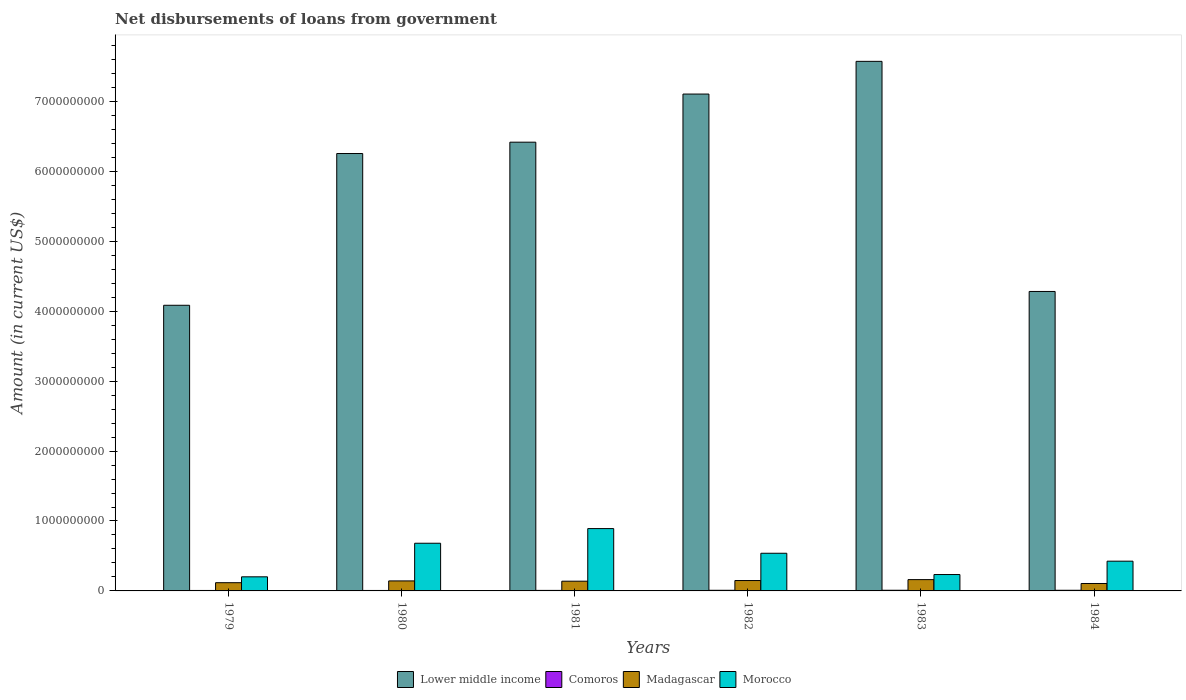How many groups of bars are there?
Your answer should be compact. 6. Are the number of bars per tick equal to the number of legend labels?
Make the answer very short. Yes. How many bars are there on the 1st tick from the right?
Your response must be concise. 4. What is the label of the 1st group of bars from the left?
Make the answer very short. 1979. In how many cases, is the number of bars for a given year not equal to the number of legend labels?
Make the answer very short. 0. What is the amount of loan disbursed from government in Madagascar in 1982?
Your response must be concise. 1.48e+08. Across all years, what is the maximum amount of loan disbursed from government in Madagascar?
Your response must be concise. 1.62e+08. Across all years, what is the minimum amount of loan disbursed from government in Morocco?
Give a very brief answer. 2.02e+08. In which year was the amount of loan disbursed from government in Lower middle income maximum?
Give a very brief answer. 1983. In which year was the amount of loan disbursed from government in Comoros minimum?
Your answer should be compact. 1980. What is the total amount of loan disbursed from government in Madagascar in the graph?
Your answer should be very brief. 8.16e+08. What is the difference between the amount of loan disbursed from government in Madagascar in 1981 and that in 1982?
Keep it short and to the point. -9.49e+06. What is the difference between the amount of loan disbursed from government in Morocco in 1980 and the amount of loan disbursed from government in Lower middle income in 1984?
Make the answer very short. -3.60e+09. What is the average amount of loan disbursed from government in Morocco per year?
Provide a short and direct response. 4.96e+08. In the year 1981, what is the difference between the amount of loan disbursed from government in Comoros and amount of loan disbursed from government in Lower middle income?
Offer a very short reply. -6.41e+09. What is the ratio of the amount of loan disbursed from government in Morocco in 1979 to that in 1982?
Provide a succinct answer. 0.37. Is the amount of loan disbursed from government in Lower middle income in 1979 less than that in 1981?
Your answer should be compact. Yes. Is the difference between the amount of loan disbursed from government in Comoros in 1979 and 1982 greater than the difference between the amount of loan disbursed from government in Lower middle income in 1979 and 1982?
Offer a very short reply. Yes. What is the difference between the highest and the second highest amount of loan disbursed from government in Lower middle income?
Ensure brevity in your answer.  4.68e+08. What is the difference between the highest and the lowest amount of loan disbursed from government in Madagascar?
Offer a very short reply. 5.54e+07. In how many years, is the amount of loan disbursed from government in Lower middle income greater than the average amount of loan disbursed from government in Lower middle income taken over all years?
Give a very brief answer. 4. What does the 2nd bar from the left in 1983 represents?
Your answer should be very brief. Comoros. What does the 4th bar from the right in 1981 represents?
Your answer should be compact. Lower middle income. How many bars are there?
Make the answer very short. 24. Does the graph contain any zero values?
Offer a very short reply. No. How many legend labels are there?
Offer a terse response. 4. How are the legend labels stacked?
Make the answer very short. Horizontal. What is the title of the graph?
Give a very brief answer. Net disbursements of loans from government. Does "OECD members" appear as one of the legend labels in the graph?
Your answer should be compact. No. What is the label or title of the X-axis?
Make the answer very short. Years. What is the label or title of the Y-axis?
Provide a short and direct response. Amount (in current US$). What is the Amount (in current US$) of Lower middle income in 1979?
Make the answer very short. 4.08e+09. What is the Amount (in current US$) in Comoros in 1979?
Provide a short and direct response. 6.61e+06. What is the Amount (in current US$) of Madagascar in 1979?
Your response must be concise. 1.18e+08. What is the Amount (in current US$) in Morocco in 1979?
Offer a very short reply. 2.02e+08. What is the Amount (in current US$) in Lower middle income in 1980?
Give a very brief answer. 6.26e+09. What is the Amount (in current US$) of Comoros in 1980?
Give a very brief answer. 6.48e+06. What is the Amount (in current US$) in Madagascar in 1980?
Your answer should be compact. 1.43e+08. What is the Amount (in current US$) of Morocco in 1980?
Your answer should be compact. 6.82e+08. What is the Amount (in current US$) in Lower middle income in 1981?
Offer a very short reply. 6.42e+09. What is the Amount (in current US$) in Comoros in 1981?
Provide a short and direct response. 7.38e+06. What is the Amount (in current US$) of Madagascar in 1981?
Ensure brevity in your answer.  1.39e+08. What is the Amount (in current US$) of Morocco in 1981?
Give a very brief answer. 8.92e+08. What is the Amount (in current US$) of Lower middle income in 1982?
Provide a succinct answer. 7.11e+09. What is the Amount (in current US$) of Comoros in 1982?
Offer a very short reply. 9.11e+06. What is the Amount (in current US$) of Madagascar in 1982?
Your answer should be very brief. 1.48e+08. What is the Amount (in current US$) in Morocco in 1982?
Ensure brevity in your answer.  5.39e+08. What is the Amount (in current US$) in Lower middle income in 1983?
Provide a short and direct response. 7.57e+09. What is the Amount (in current US$) in Comoros in 1983?
Your answer should be compact. 9.45e+06. What is the Amount (in current US$) of Madagascar in 1983?
Keep it short and to the point. 1.62e+08. What is the Amount (in current US$) of Morocco in 1983?
Offer a terse response. 2.34e+08. What is the Amount (in current US$) in Lower middle income in 1984?
Your answer should be compact. 4.28e+09. What is the Amount (in current US$) of Comoros in 1984?
Make the answer very short. 9.22e+06. What is the Amount (in current US$) in Madagascar in 1984?
Provide a short and direct response. 1.06e+08. What is the Amount (in current US$) of Morocco in 1984?
Make the answer very short. 4.25e+08. Across all years, what is the maximum Amount (in current US$) in Lower middle income?
Give a very brief answer. 7.57e+09. Across all years, what is the maximum Amount (in current US$) in Comoros?
Provide a short and direct response. 9.45e+06. Across all years, what is the maximum Amount (in current US$) in Madagascar?
Keep it short and to the point. 1.62e+08. Across all years, what is the maximum Amount (in current US$) in Morocco?
Make the answer very short. 8.92e+08. Across all years, what is the minimum Amount (in current US$) of Lower middle income?
Offer a very short reply. 4.08e+09. Across all years, what is the minimum Amount (in current US$) in Comoros?
Your response must be concise. 6.48e+06. Across all years, what is the minimum Amount (in current US$) in Madagascar?
Keep it short and to the point. 1.06e+08. Across all years, what is the minimum Amount (in current US$) in Morocco?
Make the answer very short. 2.02e+08. What is the total Amount (in current US$) of Lower middle income in the graph?
Your answer should be very brief. 3.57e+1. What is the total Amount (in current US$) of Comoros in the graph?
Give a very brief answer. 4.83e+07. What is the total Amount (in current US$) in Madagascar in the graph?
Provide a succinct answer. 8.16e+08. What is the total Amount (in current US$) in Morocco in the graph?
Ensure brevity in your answer.  2.97e+09. What is the difference between the Amount (in current US$) of Lower middle income in 1979 and that in 1980?
Offer a very short reply. -2.17e+09. What is the difference between the Amount (in current US$) of Comoros in 1979 and that in 1980?
Ensure brevity in your answer.  1.28e+05. What is the difference between the Amount (in current US$) in Madagascar in 1979 and that in 1980?
Your answer should be very brief. -2.53e+07. What is the difference between the Amount (in current US$) of Morocco in 1979 and that in 1980?
Offer a very short reply. -4.80e+08. What is the difference between the Amount (in current US$) in Lower middle income in 1979 and that in 1981?
Provide a succinct answer. -2.33e+09. What is the difference between the Amount (in current US$) in Comoros in 1979 and that in 1981?
Your answer should be compact. -7.69e+05. What is the difference between the Amount (in current US$) in Madagascar in 1979 and that in 1981?
Provide a succinct answer. -2.13e+07. What is the difference between the Amount (in current US$) of Morocco in 1979 and that in 1981?
Offer a very short reply. -6.90e+08. What is the difference between the Amount (in current US$) of Lower middle income in 1979 and that in 1982?
Provide a succinct answer. -3.02e+09. What is the difference between the Amount (in current US$) in Comoros in 1979 and that in 1982?
Your answer should be very brief. -2.50e+06. What is the difference between the Amount (in current US$) of Madagascar in 1979 and that in 1982?
Your answer should be compact. -3.08e+07. What is the difference between the Amount (in current US$) of Morocco in 1979 and that in 1982?
Give a very brief answer. -3.37e+08. What is the difference between the Amount (in current US$) in Lower middle income in 1979 and that in 1983?
Make the answer very short. -3.49e+09. What is the difference between the Amount (in current US$) in Comoros in 1979 and that in 1983?
Make the answer very short. -2.84e+06. What is the difference between the Amount (in current US$) in Madagascar in 1979 and that in 1983?
Your response must be concise. -4.39e+07. What is the difference between the Amount (in current US$) of Morocco in 1979 and that in 1983?
Your response must be concise. -3.27e+07. What is the difference between the Amount (in current US$) in Lower middle income in 1979 and that in 1984?
Provide a short and direct response. -1.98e+08. What is the difference between the Amount (in current US$) in Comoros in 1979 and that in 1984?
Your response must be concise. -2.61e+06. What is the difference between the Amount (in current US$) of Madagascar in 1979 and that in 1984?
Offer a very short reply. 1.15e+07. What is the difference between the Amount (in current US$) of Morocco in 1979 and that in 1984?
Offer a terse response. -2.24e+08. What is the difference between the Amount (in current US$) in Lower middle income in 1980 and that in 1981?
Make the answer very short. -1.62e+08. What is the difference between the Amount (in current US$) of Comoros in 1980 and that in 1981?
Ensure brevity in your answer.  -8.97e+05. What is the difference between the Amount (in current US$) in Madagascar in 1980 and that in 1981?
Make the answer very short. 4.06e+06. What is the difference between the Amount (in current US$) in Morocco in 1980 and that in 1981?
Offer a very short reply. -2.10e+08. What is the difference between the Amount (in current US$) of Lower middle income in 1980 and that in 1982?
Your response must be concise. -8.51e+08. What is the difference between the Amount (in current US$) in Comoros in 1980 and that in 1982?
Your answer should be very brief. -2.63e+06. What is the difference between the Amount (in current US$) in Madagascar in 1980 and that in 1982?
Ensure brevity in your answer.  -5.43e+06. What is the difference between the Amount (in current US$) of Morocco in 1980 and that in 1982?
Your response must be concise. 1.43e+08. What is the difference between the Amount (in current US$) in Lower middle income in 1980 and that in 1983?
Provide a short and direct response. -1.32e+09. What is the difference between the Amount (in current US$) in Comoros in 1980 and that in 1983?
Give a very brief answer. -2.97e+06. What is the difference between the Amount (in current US$) in Madagascar in 1980 and that in 1983?
Provide a short and direct response. -1.86e+07. What is the difference between the Amount (in current US$) in Morocco in 1980 and that in 1983?
Provide a succinct answer. 4.47e+08. What is the difference between the Amount (in current US$) of Lower middle income in 1980 and that in 1984?
Give a very brief answer. 1.97e+09. What is the difference between the Amount (in current US$) in Comoros in 1980 and that in 1984?
Your answer should be very brief. -2.73e+06. What is the difference between the Amount (in current US$) in Madagascar in 1980 and that in 1984?
Keep it short and to the point. 3.68e+07. What is the difference between the Amount (in current US$) of Morocco in 1980 and that in 1984?
Give a very brief answer. 2.56e+08. What is the difference between the Amount (in current US$) of Lower middle income in 1981 and that in 1982?
Your response must be concise. -6.88e+08. What is the difference between the Amount (in current US$) of Comoros in 1981 and that in 1982?
Your answer should be very brief. -1.73e+06. What is the difference between the Amount (in current US$) in Madagascar in 1981 and that in 1982?
Make the answer very short. -9.49e+06. What is the difference between the Amount (in current US$) in Morocco in 1981 and that in 1982?
Your response must be concise. 3.53e+08. What is the difference between the Amount (in current US$) of Lower middle income in 1981 and that in 1983?
Offer a terse response. -1.16e+09. What is the difference between the Amount (in current US$) of Comoros in 1981 and that in 1983?
Your answer should be very brief. -2.07e+06. What is the difference between the Amount (in current US$) of Madagascar in 1981 and that in 1983?
Ensure brevity in your answer.  -2.26e+07. What is the difference between the Amount (in current US$) of Morocco in 1981 and that in 1983?
Provide a succinct answer. 6.57e+08. What is the difference between the Amount (in current US$) of Lower middle income in 1981 and that in 1984?
Offer a very short reply. 2.13e+09. What is the difference between the Amount (in current US$) in Comoros in 1981 and that in 1984?
Make the answer very short. -1.84e+06. What is the difference between the Amount (in current US$) of Madagascar in 1981 and that in 1984?
Ensure brevity in your answer.  3.27e+07. What is the difference between the Amount (in current US$) in Morocco in 1981 and that in 1984?
Provide a succinct answer. 4.66e+08. What is the difference between the Amount (in current US$) of Lower middle income in 1982 and that in 1983?
Your answer should be very brief. -4.68e+08. What is the difference between the Amount (in current US$) in Comoros in 1982 and that in 1983?
Provide a short and direct response. -3.41e+05. What is the difference between the Amount (in current US$) of Madagascar in 1982 and that in 1983?
Provide a short and direct response. -1.31e+07. What is the difference between the Amount (in current US$) of Morocco in 1982 and that in 1983?
Offer a very short reply. 3.04e+08. What is the difference between the Amount (in current US$) in Lower middle income in 1982 and that in 1984?
Your answer should be compact. 2.82e+09. What is the difference between the Amount (in current US$) of Comoros in 1982 and that in 1984?
Give a very brief answer. -1.07e+05. What is the difference between the Amount (in current US$) in Madagascar in 1982 and that in 1984?
Make the answer very short. 4.22e+07. What is the difference between the Amount (in current US$) of Morocco in 1982 and that in 1984?
Make the answer very short. 1.13e+08. What is the difference between the Amount (in current US$) of Lower middle income in 1983 and that in 1984?
Provide a short and direct response. 3.29e+09. What is the difference between the Amount (in current US$) in Comoros in 1983 and that in 1984?
Offer a terse response. 2.34e+05. What is the difference between the Amount (in current US$) in Madagascar in 1983 and that in 1984?
Your answer should be compact. 5.54e+07. What is the difference between the Amount (in current US$) of Morocco in 1983 and that in 1984?
Offer a very short reply. -1.91e+08. What is the difference between the Amount (in current US$) of Lower middle income in 1979 and the Amount (in current US$) of Comoros in 1980?
Provide a succinct answer. 4.08e+09. What is the difference between the Amount (in current US$) in Lower middle income in 1979 and the Amount (in current US$) in Madagascar in 1980?
Make the answer very short. 3.94e+09. What is the difference between the Amount (in current US$) in Lower middle income in 1979 and the Amount (in current US$) in Morocco in 1980?
Ensure brevity in your answer.  3.40e+09. What is the difference between the Amount (in current US$) in Comoros in 1979 and the Amount (in current US$) in Madagascar in 1980?
Provide a succinct answer. -1.36e+08. What is the difference between the Amount (in current US$) in Comoros in 1979 and the Amount (in current US$) in Morocco in 1980?
Your answer should be very brief. -6.75e+08. What is the difference between the Amount (in current US$) of Madagascar in 1979 and the Amount (in current US$) of Morocco in 1980?
Make the answer very short. -5.64e+08. What is the difference between the Amount (in current US$) in Lower middle income in 1979 and the Amount (in current US$) in Comoros in 1981?
Make the answer very short. 4.08e+09. What is the difference between the Amount (in current US$) in Lower middle income in 1979 and the Amount (in current US$) in Madagascar in 1981?
Your response must be concise. 3.95e+09. What is the difference between the Amount (in current US$) of Lower middle income in 1979 and the Amount (in current US$) of Morocco in 1981?
Offer a very short reply. 3.19e+09. What is the difference between the Amount (in current US$) in Comoros in 1979 and the Amount (in current US$) in Madagascar in 1981?
Keep it short and to the point. -1.32e+08. What is the difference between the Amount (in current US$) of Comoros in 1979 and the Amount (in current US$) of Morocco in 1981?
Offer a very short reply. -8.85e+08. What is the difference between the Amount (in current US$) of Madagascar in 1979 and the Amount (in current US$) of Morocco in 1981?
Your response must be concise. -7.74e+08. What is the difference between the Amount (in current US$) of Lower middle income in 1979 and the Amount (in current US$) of Comoros in 1982?
Make the answer very short. 4.08e+09. What is the difference between the Amount (in current US$) of Lower middle income in 1979 and the Amount (in current US$) of Madagascar in 1982?
Provide a succinct answer. 3.94e+09. What is the difference between the Amount (in current US$) of Lower middle income in 1979 and the Amount (in current US$) of Morocco in 1982?
Ensure brevity in your answer.  3.55e+09. What is the difference between the Amount (in current US$) of Comoros in 1979 and the Amount (in current US$) of Madagascar in 1982?
Your answer should be very brief. -1.42e+08. What is the difference between the Amount (in current US$) in Comoros in 1979 and the Amount (in current US$) in Morocco in 1982?
Provide a succinct answer. -5.32e+08. What is the difference between the Amount (in current US$) in Madagascar in 1979 and the Amount (in current US$) in Morocco in 1982?
Your response must be concise. -4.21e+08. What is the difference between the Amount (in current US$) of Lower middle income in 1979 and the Amount (in current US$) of Comoros in 1983?
Your response must be concise. 4.08e+09. What is the difference between the Amount (in current US$) in Lower middle income in 1979 and the Amount (in current US$) in Madagascar in 1983?
Keep it short and to the point. 3.92e+09. What is the difference between the Amount (in current US$) of Lower middle income in 1979 and the Amount (in current US$) of Morocco in 1983?
Provide a short and direct response. 3.85e+09. What is the difference between the Amount (in current US$) in Comoros in 1979 and the Amount (in current US$) in Madagascar in 1983?
Offer a very short reply. -1.55e+08. What is the difference between the Amount (in current US$) in Comoros in 1979 and the Amount (in current US$) in Morocco in 1983?
Keep it short and to the point. -2.28e+08. What is the difference between the Amount (in current US$) of Madagascar in 1979 and the Amount (in current US$) of Morocco in 1983?
Ensure brevity in your answer.  -1.17e+08. What is the difference between the Amount (in current US$) in Lower middle income in 1979 and the Amount (in current US$) in Comoros in 1984?
Your answer should be very brief. 4.08e+09. What is the difference between the Amount (in current US$) in Lower middle income in 1979 and the Amount (in current US$) in Madagascar in 1984?
Offer a terse response. 3.98e+09. What is the difference between the Amount (in current US$) of Lower middle income in 1979 and the Amount (in current US$) of Morocco in 1984?
Give a very brief answer. 3.66e+09. What is the difference between the Amount (in current US$) of Comoros in 1979 and the Amount (in current US$) of Madagascar in 1984?
Your answer should be compact. -9.97e+07. What is the difference between the Amount (in current US$) in Comoros in 1979 and the Amount (in current US$) in Morocco in 1984?
Ensure brevity in your answer.  -4.19e+08. What is the difference between the Amount (in current US$) in Madagascar in 1979 and the Amount (in current US$) in Morocco in 1984?
Give a very brief answer. -3.08e+08. What is the difference between the Amount (in current US$) of Lower middle income in 1980 and the Amount (in current US$) of Comoros in 1981?
Make the answer very short. 6.25e+09. What is the difference between the Amount (in current US$) of Lower middle income in 1980 and the Amount (in current US$) of Madagascar in 1981?
Offer a very short reply. 6.12e+09. What is the difference between the Amount (in current US$) of Lower middle income in 1980 and the Amount (in current US$) of Morocco in 1981?
Your answer should be compact. 5.36e+09. What is the difference between the Amount (in current US$) of Comoros in 1980 and the Amount (in current US$) of Madagascar in 1981?
Give a very brief answer. -1.33e+08. What is the difference between the Amount (in current US$) of Comoros in 1980 and the Amount (in current US$) of Morocco in 1981?
Your answer should be compact. -8.85e+08. What is the difference between the Amount (in current US$) in Madagascar in 1980 and the Amount (in current US$) in Morocco in 1981?
Make the answer very short. -7.48e+08. What is the difference between the Amount (in current US$) in Lower middle income in 1980 and the Amount (in current US$) in Comoros in 1982?
Keep it short and to the point. 6.25e+09. What is the difference between the Amount (in current US$) of Lower middle income in 1980 and the Amount (in current US$) of Madagascar in 1982?
Give a very brief answer. 6.11e+09. What is the difference between the Amount (in current US$) of Lower middle income in 1980 and the Amount (in current US$) of Morocco in 1982?
Give a very brief answer. 5.72e+09. What is the difference between the Amount (in current US$) of Comoros in 1980 and the Amount (in current US$) of Madagascar in 1982?
Offer a very short reply. -1.42e+08. What is the difference between the Amount (in current US$) of Comoros in 1980 and the Amount (in current US$) of Morocco in 1982?
Keep it short and to the point. -5.32e+08. What is the difference between the Amount (in current US$) in Madagascar in 1980 and the Amount (in current US$) in Morocco in 1982?
Your response must be concise. -3.96e+08. What is the difference between the Amount (in current US$) in Lower middle income in 1980 and the Amount (in current US$) in Comoros in 1983?
Ensure brevity in your answer.  6.25e+09. What is the difference between the Amount (in current US$) in Lower middle income in 1980 and the Amount (in current US$) in Madagascar in 1983?
Ensure brevity in your answer.  6.09e+09. What is the difference between the Amount (in current US$) in Lower middle income in 1980 and the Amount (in current US$) in Morocco in 1983?
Your answer should be very brief. 6.02e+09. What is the difference between the Amount (in current US$) of Comoros in 1980 and the Amount (in current US$) of Madagascar in 1983?
Provide a succinct answer. -1.55e+08. What is the difference between the Amount (in current US$) in Comoros in 1980 and the Amount (in current US$) in Morocco in 1983?
Your answer should be compact. -2.28e+08. What is the difference between the Amount (in current US$) of Madagascar in 1980 and the Amount (in current US$) of Morocco in 1983?
Give a very brief answer. -9.12e+07. What is the difference between the Amount (in current US$) of Lower middle income in 1980 and the Amount (in current US$) of Comoros in 1984?
Your response must be concise. 6.25e+09. What is the difference between the Amount (in current US$) of Lower middle income in 1980 and the Amount (in current US$) of Madagascar in 1984?
Your answer should be compact. 6.15e+09. What is the difference between the Amount (in current US$) in Lower middle income in 1980 and the Amount (in current US$) in Morocco in 1984?
Make the answer very short. 5.83e+09. What is the difference between the Amount (in current US$) of Comoros in 1980 and the Amount (in current US$) of Madagascar in 1984?
Ensure brevity in your answer.  -9.98e+07. What is the difference between the Amount (in current US$) in Comoros in 1980 and the Amount (in current US$) in Morocco in 1984?
Offer a very short reply. -4.19e+08. What is the difference between the Amount (in current US$) in Madagascar in 1980 and the Amount (in current US$) in Morocco in 1984?
Offer a terse response. -2.82e+08. What is the difference between the Amount (in current US$) in Lower middle income in 1981 and the Amount (in current US$) in Comoros in 1982?
Your response must be concise. 6.41e+09. What is the difference between the Amount (in current US$) in Lower middle income in 1981 and the Amount (in current US$) in Madagascar in 1982?
Give a very brief answer. 6.27e+09. What is the difference between the Amount (in current US$) in Lower middle income in 1981 and the Amount (in current US$) in Morocco in 1982?
Offer a very short reply. 5.88e+09. What is the difference between the Amount (in current US$) in Comoros in 1981 and the Amount (in current US$) in Madagascar in 1982?
Give a very brief answer. -1.41e+08. What is the difference between the Amount (in current US$) of Comoros in 1981 and the Amount (in current US$) of Morocco in 1982?
Ensure brevity in your answer.  -5.31e+08. What is the difference between the Amount (in current US$) of Madagascar in 1981 and the Amount (in current US$) of Morocco in 1982?
Make the answer very short. -4.00e+08. What is the difference between the Amount (in current US$) in Lower middle income in 1981 and the Amount (in current US$) in Comoros in 1983?
Make the answer very short. 6.41e+09. What is the difference between the Amount (in current US$) in Lower middle income in 1981 and the Amount (in current US$) in Madagascar in 1983?
Your response must be concise. 6.26e+09. What is the difference between the Amount (in current US$) in Lower middle income in 1981 and the Amount (in current US$) in Morocco in 1983?
Provide a succinct answer. 6.18e+09. What is the difference between the Amount (in current US$) in Comoros in 1981 and the Amount (in current US$) in Madagascar in 1983?
Give a very brief answer. -1.54e+08. What is the difference between the Amount (in current US$) of Comoros in 1981 and the Amount (in current US$) of Morocco in 1983?
Keep it short and to the point. -2.27e+08. What is the difference between the Amount (in current US$) in Madagascar in 1981 and the Amount (in current US$) in Morocco in 1983?
Provide a succinct answer. -9.53e+07. What is the difference between the Amount (in current US$) of Lower middle income in 1981 and the Amount (in current US$) of Comoros in 1984?
Your response must be concise. 6.41e+09. What is the difference between the Amount (in current US$) of Lower middle income in 1981 and the Amount (in current US$) of Madagascar in 1984?
Keep it short and to the point. 6.31e+09. What is the difference between the Amount (in current US$) of Lower middle income in 1981 and the Amount (in current US$) of Morocco in 1984?
Provide a succinct answer. 5.99e+09. What is the difference between the Amount (in current US$) in Comoros in 1981 and the Amount (in current US$) in Madagascar in 1984?
Provide a succinct answer. -9.89e+07. What is the difference between the Amount (in current US$) in Comoros in 1981 and the Amount (in current US$) in Morocco in 1984?
Ensure brevity in your answer.  -4.18e+08. What is the difference between the Amount (in current US$) of Madagascar in 1981 and the Amount (in current US$) of Morocco in 1984?
Your response must be concise. -2.86e+08. What is the difference between the Amount (in current US$) of Lower middle income in 1982 and the Amount (in current US$) of Comoros in 1983?
Keep it short and to the point. 7.10e+09. What is the difference between the Amount (in current US$) of Lower middle income in 1982 and the Amount (in current US$) of Madagascar in 1983?
Offer a terse response. 6.94e+09. What is the difference between the Amount (in current US$) in Lower middle income in 1982 and the Amount (in current US$) in Morocco in 1983?
Give a very brief answer. 6.87e+09. What is the difference between the Amount (in current US$) in Comoros in 1982 and the Amount (in current US$) in Madagascar in 1983?
Your response must be concise. -1.53e+08. What is the difference between the Amount (in current US$) in Comoros in 1982 and the Amount (in current US$) in Morocco in 1983?
Offer a very short reply. -2.25e+08. What is the difference between the Amount (in current US$) in Madagascar in 1982 and the Amount (in current US$) in Morocco in 1983?
Make the answer very short. -8.58e+07. What is the difference between the Amount (in current US$) of Lower middle income in 1982 and the Amount (in current US$) of Comoros in 1984?
Your response must be concise. 7.10e+09. What is the difference between the Amount (in current US$) of Lower middle income in 1982 and the Amount (in current US$) of Madagascar in 1984?
Make the answer very short. 7.00e+09. What is the difference between the Amount (in current US$) in Lower middle income in 1982 and the Amount (in current US$) in Morocco in 1984?
Offer a very short reply. 6.68e+09. What is the difference between the Amount (in current US$) of Comoros in 1982 and the Amount (in current US$) of Madagascar in 1984?
Offer a terse response. -9.72e+07. What is the difference between the Amount (in current US$) in Comoros in 1982 and the Amount (in current US$) in Morocco in 1984?
Ensure brevity in your answer.  -4.16e+08. What is the difference between the Amount (in current US$) of Madagascar in 1982 and the Amount (in current US$) of Morocco in 1984?
Make the answer very short. -2.77e+08. What is the difference between the Amount (in current US$) in Lower middle income in 1983 and the Amount (in current US$) in Comoros in 1984?
Keep it short and to the point. 7.56e+09. What is the difference between the Amount (in current US$) of Lower middle income in 1983 and the Amount (in current US$) of Madagascar in 1984?
Your answer should be very brief. 7.47e+09. What is the difference between the Amount (in current US$) of Lower middle income in 1983 and the Amount (in current US$) of Morocco in 1984?
Your answer should be compact. 7.15e+09. What is the difference between the Amount (in current US$) of Comoros in 1983 and the Amount (in current US$) of Madagascar in 1984?
Your answer should be very brief. -9.68e+07. What is the difference between the Amount (in current US$) of Comoros in 1983 and the Amount (in current US$) of Morocco in 1984?
Provide a short and direct response. -4.16e+08. What is the difference between the Amount (in current US$) of Madagascar in 1983 and the Amount (in current US$) of Morocco in 1984?
Your answer should be very brief. -2.64e+08. What is the average Amount (in current US$) of Lower middle income per year?
Provide a succinct answer. 5.95e+09. What is the average Amount (in current US$) in Comoros per year?
Make the answer very short. 8.04e+06. What is the average Amount (in current US$) in Madagascar per year?
Offer a very short reply. 1.36e+08. What is the average Amount (in current US$) in Morocco per year?
Your response must be concise. 4.96e+08. In the year 1979, what is the difference between the Amount (in current US$) of Lower middle income and Amount (in current US$) of Comoros?
Provide a succinct answer. 4.08e+09. In the year 1979, what is the difference between the Amount (in current US$) of Lower middle income and Amount (in current US$) of Madagascar?
Make the answer very short. 3.97e+09. In the year 1979, what is the difference between the Amount (in current US$) of Lower middle income and Amount (in current US$) of Morocco?
Keep it short and to the point. 3.88e+09. In the year 1979, what is the difference between the Amount (in current US$) in Comoros and Amount (in current US$) in Madagascar?
Make the answer very short. -1.11e+08. In the year 1979, what is the difference between the Amount (in current US$) in Comoros and Amount (in current US$) in Morocco?
Make the answer very short. -1.95e+08. In the year 1979, what is the difference between the Amount (in current US$) in Madagascar and Amount (in current US$) in Morocco?
Offer a very short reply. -8.39e+07. In the year 1980, what is the difference between the Amount (in current US$) in Lower middle income and Amount (in current US$) in Comoros?
Offer a very short reply. 6.25e+09. In the year 1980, what is the difference between the Amount (in current US$) in Lower middle income and Amount (in current US$) in Madagascar?
Your response must be concise. 6.11e+09. In the year 1980, what is the difference between the Amount (in current US$) of Lower middle income and Amount (in current US$) of Morocco?
Ensure brevity in your answer.  5.57e+09. In the year 1980, what is the difference between the Amount (in current US$) in Comoros and Amount (in current US$) in Madagascar?
Keep it short and to the point. -1.37e+08. In the year 1980, what is the difference between the Amount (in current US$) in Comoros and Amount (in current US$) in Morocco?
Provide a succinct answer. -6.75e+08. In the year 1980, what is the difference between the Amount (in current US$) in Madagascar and Amount (in current US$) in Morocco?
Offer a terse response. -5.39e+08. In the year 1981, what is the difference between the Amount (in current US$) of Lower middle income and Amount (in current US$) of Comoros?
Offer a terse response. 6.41e+09. In the year 1981, what is the difference between the Amount (in current US$) in Lower middle income and Amount (in current US$) in Madagascar?
Keep it short and to the point. 6.28e+09. In the year 1981, what is the difference between the Amount (in current US$) of Lower middle income and Amount (in current US$) of Morocco?
Offer a terse response. 5.53e+09. In the year 1981, what is the difference between the Amount (in current US$) of Comoros and Amount (in current US$) of Madagascar?
Provide a short and direct response. -1.32e+08. In the year 1981, what is the difference between the Amount (in current US$) of Comoros and Amount (in current US$) of Morocco?
Your answer should be compact. -8.84e+08. In the year 1981, what is the difference between the Amount (in current US$) in Madagascar and Amount (in current US$) in Morocco?
Your response must be concise. -7.53e+08. In the year 1982, what is the difference between the Amount (in current US$) of Lower middle income and Amount (in current US$) of Comoros?
Provide a short and direct response. 7.10e+09. In the year 1982, what is the difference between the Amount (in current US$) in Lower middle income and Amount (in current US$) in Madagascar?
Keep it short and to the point. 6.96e+09. In the year 1982, what is the difference between the Amount (in current US$) of Lower middle income and Amount (in current US$) of Morocco?
Give a very brief answer. 6.57e+09. In the year 1982, what is the difference between the Amount (in current US$) in Comoros and Amount (in current US$) in Madagascar?
Ensure brevity in your answer.  -1.39e+08. In the year 1982, what is the difference between the Amount (in current US$) in Comoros and Amount (in current US$) in Morocco?
Provide a succinct answer. -5.29e+08. In the year 1982, what is the difference between the Amount (in current US$) of Madagascar and Amount (in current US$) of Morocco?
Provide a short and direct response. -3.90e+08. In the year 1983, what is the difference between the Amount (in current US$) in Lower middle income and Amount (in current US$) in Comoros?
Offer a very short reply. 7.56e+09. In the year 1983, what is the difference between the Amount (in current US$) of Lower middle income and Amount (in current US$) of Madagascar?
Your answer should be very brief. 7.41e+09. In the year 1983, what is the difference between the Amount (in current US$) of Lower middle income and Amount (in current US$) of Morocco?
Provide a short and direct response. 7.34e+09. In the year 1983, what is the difference between the Amount (in current US$) in Comoros and Amount (in current US$) in Madagascar?
Offer a terse response. -1.52e+08. In the year 1983, what is the difference between the Amount (in current US$) in Comoros and Amount (in current US$) in Morocco?
Offer a terse response. -2.25e+08. In the year 1983, what is the difference between the Amount (in current US$) of Madagascar and Amount (in current US$) of Morocco?
Keep it short and to the point. -7.27e+07. In the year 1984, what is the difference between the Amount (in current US$) of Lower middle income and Amount (in current US$) of Comoros?
Your answer should be very brief. 4.27e+09. In the year 1984, what is the difference between the Amount (in current US$) of Lower middle income and Amount (in current US$) of Madagascar?
Make the answer very short. 4.18e+09. In the year 1984, what is the difference between the Amount (in current US$) of Lower middle income and Amount (in current US$) of Morocco?
Your response must be concise. 3.86e+09. In the year 1984, what is the difference between the Amount (in current US$) of Comoros and Amount (in current US$) of Madagascar?
Keep it short and to the point. -9.71e+07. In the year 1984, what is the difference between the Amount (in current US$) of Comoros and Amount (in current US$) of Morocco?
Your answer should be very brief. -4.16e+08. In the year 1984, what is the difference between the Amount (in current US$) of Madagascar and Amount (in current US$) of Morocco?
Your answer should be compact. -3.19e+08. What is the ratio of the Amount (in current US$) of Lower middle income in 1979 to that in 1980?
Your answer should be very brief. 0.65. What is the ratio of the Amount (in current US$) of Comoros in 1979 to that in 1980?
Offer a very short reply. 1.02. What is the ratio of the Amount (in current US$) in Madagascar in 1979 to that in 1980?
Offer a very short reply. 0.82. What is the ratio of the Amount (in current US$) of Morocco in 1979 to that in 1980?
Provide a short and direct response. 0.3. What is the ratio of the Amount (in current US$) of Lower middle income in 1979 to that in 1981?
Offer a very short reply. 0.64. What is the ratio of the Amount (in current US$) in Comoros in 1979 to that in 1981?
Ensure brevity in your answer.  0.9. What is the ratio of the Amount (in current US$) in Madagascar in 1979 to that in 1981?
Your response must be concise. 0.85. What is the ratio of the Amount (in current US$) of Morocco in 1979 to that in 1981?
Keep it short and to the point. 0.23. What is the ratio of the Amount (in current US$) in Lower middle income in 1979 to that in 1982?
Your answer should be very brief. 0.57. What is the ratio of the Amount (in current US$) of Comoros in 1979 to that in 1982?
Offer a terse response. 0.73. What is the ratio of the Amount (in current US$) in Madagascar in 1979 to that in 1982?
Your answer should be compact. 0.79. What is the ratio of the Amount (in current US$) in Morocco in 1979 to that in 1982?
Your answer should be very brief. 0.37. What is the ratio of the Amount (in current US$) in Lower middle income in 1979 to that in 1983?
Offer a terse response. 0.54. What is the ratio of the Amount (in current US$) of Comoros in 1979 to that in 1983?
Provide a short and direct response. 0.7. What is the ratio of the Amount (in current US$) of Madagascar in 1979 to that in 1983?
Offer a very short reply. 0.73. What is the ratio of the Amount (in current US$) in Morocco in 1979 to that in 1983?
Provide a short and direct response. 0.86. What is the ratio of the Amount (in current US$) in Lower middle income in 1979 to that in 1984?
Provide a succinct answer. 0.95. What is the ratio of the Amount (in current US$) of Comoros in 1979 to that in 1984?
Ensure brevity in your answer.  0.72. What is the ratio of the Amount (in current US$) in Madagascar in 1979 to that in 1984?
Keep it short and to the point. 1.11. What is the ratio of the Amount (in current US$) of Morocco in 1979 to that in 1984?
Your answer should be very brief. 0.47. What is the ratio of the Amount (in current US$) in Lower middle income in 1980 to that in 1981?
Offer a terse response. 0.97. What is the ratio of the Amount (in current US$) in Comoros in 1980 to that in 1981?
Your response must be concise. 0.88. What is the ratio of the Amount (in current US$) of Madagascar in 1980 to that in 1981?
Make the answer very short. 1.03. What is the ratio of the Amount (in current US$) in Morocco in 1980 to that in 1981?
Your response must be concise. 0.76. What is the ratio of the Amount (in current US$) in Lower middle income in 1980 to that in 1982?
Your answer should be very brief. 0.88. What is the ratio of the Amount (in current US$) in Comoros in 1980 to that in 1982?
Your response must be concise. 0.71. What is the ratio of the Amount (in current US$) in Madagascar in 1980 to that in 1982?
Offer a very short reply. 0.96. What is the ratio of the Amount (in current US$) of Morocco in 1980 to that in 1982?
Ensure brevity in your answer.  1.27. What is the ratio of the Amount (in current US$) of Lower middle income in 1980 to that in 1983?
Keep it short and to the point. 0.83. What is the ratio of the Amount (in current US$) of Comoros in 1980 to that in 1983?
Your response must be concise. 0.69. What is the ratio of the Amount (in current US$) in Madagascar in 1980 to that in 1983?
Offer a very short reply. 0.89. What is the ratio of the Amount (in current US$) of Morocco in 1980 to that in 1983?
Offer a terse response. 2.91. What is the ratio of the Amount (in current US$) of Lower middle income in 1980 to that in 1984?
Keep it short and to the point. 1.46. What is the ratio of the Amount (in current US$) in Comoros in 1980 to that in 1984?
Give a very brief answer. 0.7. What is the ratio of the Amount (in current US$) in Madagascar in 1980 to that in 1984?
Provide a short and direct response. 1.35. What is the ratio of the Amount (in current US$) in Morocco in 1980 to that in 1984?
Provide a short and direct response. 1.6. What is the ratio of the Amount (in current US$) in Lower middle income in 1981 to that in 1982?
Make the answer very short. 0.9. What is the ratio of the Amount (in current US$) in Comoros in 1981 to that in 1982?
Offer a terse response. 0.81. What is the ratio of the Amount (in current US$) in Madagascar in 1981 to that in 1982?
Give a very brief answer. 0.94. What is the ratio of the Amount (in current US$) of Morocco in 1981 to that in 1982?
Your answer should be compact. 1.66. What is the ratio of the Amount (in current US$) in Lower middle income in 1981 to that in 1983?
Your answer should be very brief. 0.85. What is the ratio of the Amount (in current US$) of Comoros in 1981 to that in 1983?
Provide a succinct answer. 0.78. What is the ratio of the Amount (in current US$) in Madagascar in 1981 to that in 1983?
Make the answer very short. 0.86. What is the ratio of the Amount (in current US$) in Morocco in 1981 to that in 1983?
Offer a terse response. 3.81. What is the ratio of the Amount (in current US$) in Lower middle income in 1981 to that in 1984?
Make the answer very short. 1.5. What is the ratio of the Amount (in current US$) of Comoros in 1981 to that in 1984?
Ensure brevity in your answer.  0.8. What is the ratio of the Amount (in current US$) of Madagascar in 1981 to that in 1984?
Provide a succinct answer. 1.31. What is the ratio of the Amount (in current US$) in Morocco in 1981 to that in 1984?
Your answer should be very brief. 2.1. What is the ratio of the Amount (in current US$) of Lower middle income in 1982 to that in 1983?
Your answer should be compact. 0.94. What is the ratio of the Amount (in current US$) of Comoros in 1982 to that in 1983?
Your answer should be very brief. 0.96. What is the ratio of the Amount (in current US$) of Madagascar in 1982 to that in 1983?
Your answer should be compact. 0.92. What is the ratio of the Amount (in current US$) of Morocco in 1982 to that in 1983?
Give a very brief answer. 2.3. What is the ratio of the Amount (in current US$) of Lower middle income in 1982 to that in 1984?
Offer a very short reply. 1.66. What is the ratio of the Amount (in current US$) of Comoros in 1982 to that in 1984?
Provide a short and direct response. 0.99. What is the ratio of the Amount (in current US$) in Madagascar in 1982 to that in 1984?
Provide a short and direct response. 1.4. What is the ratio of the Amount (in current US$) of Morocco in 1982 to that in 1984?
Your answer should be very brief. 1.27. What is the ratio of the Amount (in current US$) of Lower middle income in 1983 to that in 1984?
Offer a very short reply. 1.77. What is the ratio of the Amount (in current US$) of Comoros in 1983 to that in 1984?
Keep it short and to the point. 1.03. What is the ratio of the Amount (in current US$) in Madagascar in 1983 to that in 1984?
Ensure brevity in your answer.  1.52. What is the ratio of the Amount (in current US$) of Morocco in 1983 to that in 1984?
Your answer should be very brief. 0.55. What is the difference between the highest and the second highest Amount (in current US$) of Lower middle income?
Your answer should be very brief. 4.68e+08. What is the difference between the highest and the second highest Amount (in current US$) of Comoros?
Provide a succinct answer. 2.34e+05. What is the difference between the highest and the second highest Amount (in current US$) in Madagascar?
Your response must be concise. 1.31e+07. What is the difference between the highest and the second highest Amount (in current US$) in Morocco?
Keep it short and to the point. 2.10e+08. What is the difference between the highest and the lowest Amount (in current US$) in Lower middle income?
Your answer should be very brief. 3.49e+09. What is the difference between the highest and the lowest Amount (in current US$) of Comoros?
Your answer should be compact. 2.97e+06. What is the difference between the highest and the lowest Amount (in current US$) in Madagascar?
Offer a terse response. 5.54e+07. What is the difference between the highest and the lowest Amount (in current US$) of Morocco?
Give a very brief answer. 6.90e+08. 